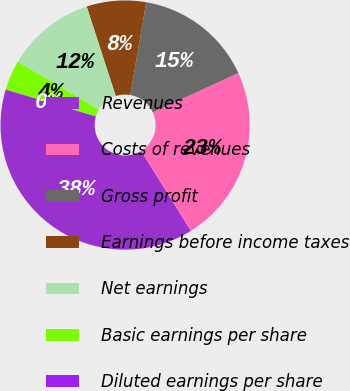Convert chart. <chart><loc_0><loc_0><loc_500><loc_500><pie_chart><fcel>Revenues<fcel>Costs of revenues<fcel>Gross profit<fcel>Earnings before income taxes<fcel>Net earnings<fcel>Basic earnings per share<fcel>Diluted earnings per share<nl><fcel>38.44%<fcel>23.0%<fcel>15.44%<fcel>7.7%<fcel>11.54%<fcel>3.86%<fcel>0.02%<nl></chart> 